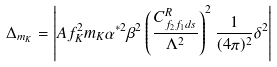<formula> <loc_0><loc_0><loc_500><loc_500>\Delta _ { m _ { K } } = \left | A f _ { K } ^ { 2 } m _ { K } \alpha ^ { * 2 } \beta ^ { 2 } \left ( \frac { C ^ { R } _ { f _ { 2 } f _ { 1 } d s } } { \Lambda ^ { 2 } } \right ) ^ { 2 } \frac { 1 } { ( 4 \pi ) ^ { 2 } } \delta ^ { 2 } \right |</formula> 